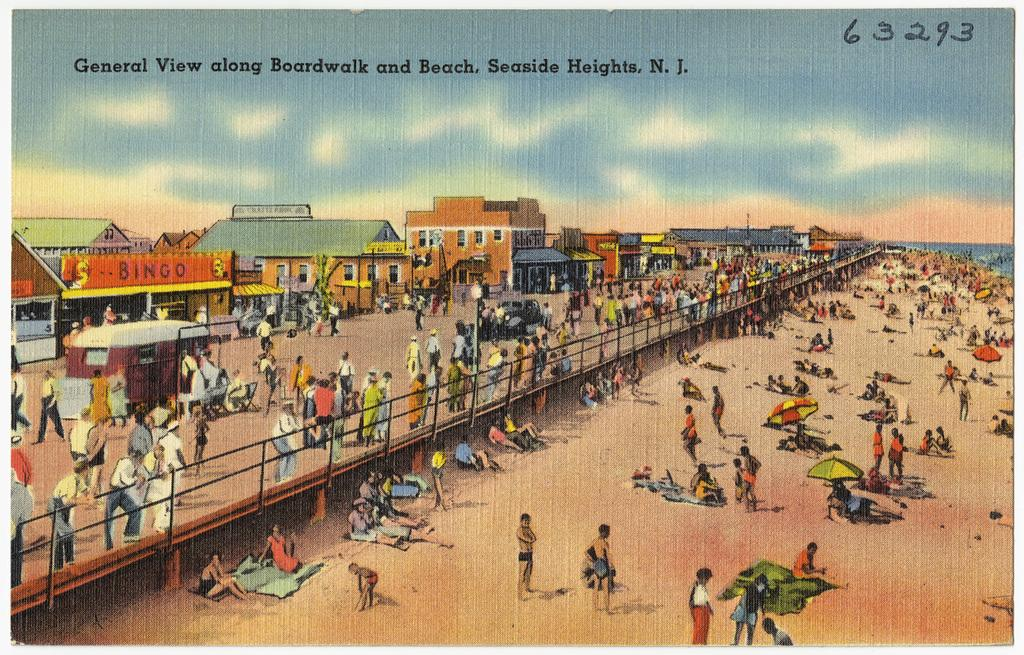<image>
Summarize the visual content of the image. An old post card or image of general view along boardwalk and beach in Seaside Heights, N.J. 